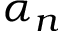<formula> <loc_0><loc_0><loc_500><loc_500>\alpha _ { n }</formula> 